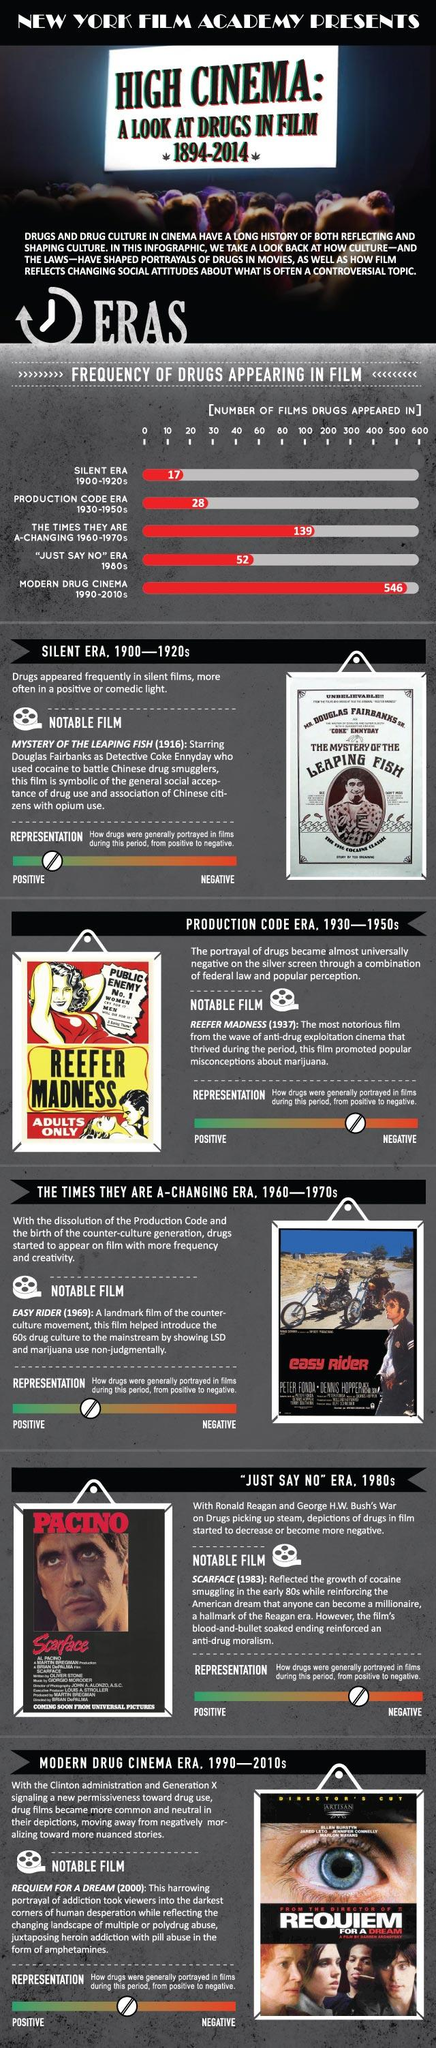Outline some significant characteristics in this image. The notable movie of the 60s era was "Easy Rider". The second highest number of drug appearances in films was during the 1960s and 1970s. Al Pacino played the lead role in a notable movie of the "Just say No" era. During the production code era, movies portrayed drug use in a negative light. The lead characters in the notable movie of the 60s era were Peter Fonda and Dennis Hopper. 